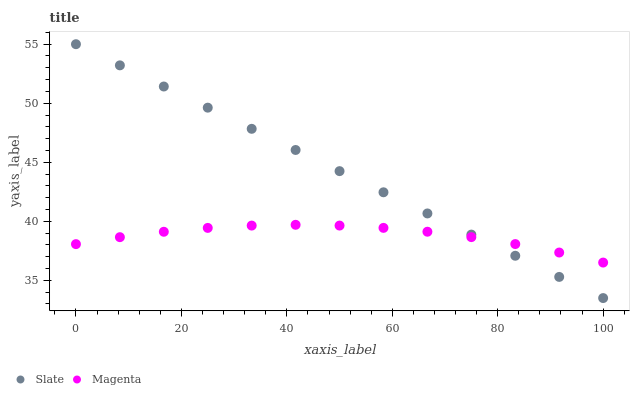Does Magenta have the minimum area under the curve?
Answer yes or no. Yes. Does Slate have the maximum area under the curve?
Answer yes or no. Yes. Does Magenta have the maximum area under the curve?
Answer yes or no. No. Is Slate the smoothest?
Answer yes or no. Yes. Is Magenta the roughest?
Answer yes or no. Yes. Is Magenta the smoothest?
Answer yes or no. No. Does Slate have the lowest value?
Answer yes or no. Yes. Does Magenta have the lowest value?
Answer yes or no. No. Does Slate have the highest value?
Answer yes or no. Yes. Does Magenta have the highest value?
Answer yes or no. No. Does Slate intersect Magenta?
Answer yes or no. Yes. Is Slate less than Magenta?
Answer yes or no. No. Is Slate greater than Magenta?
Answer yes or no. No. 